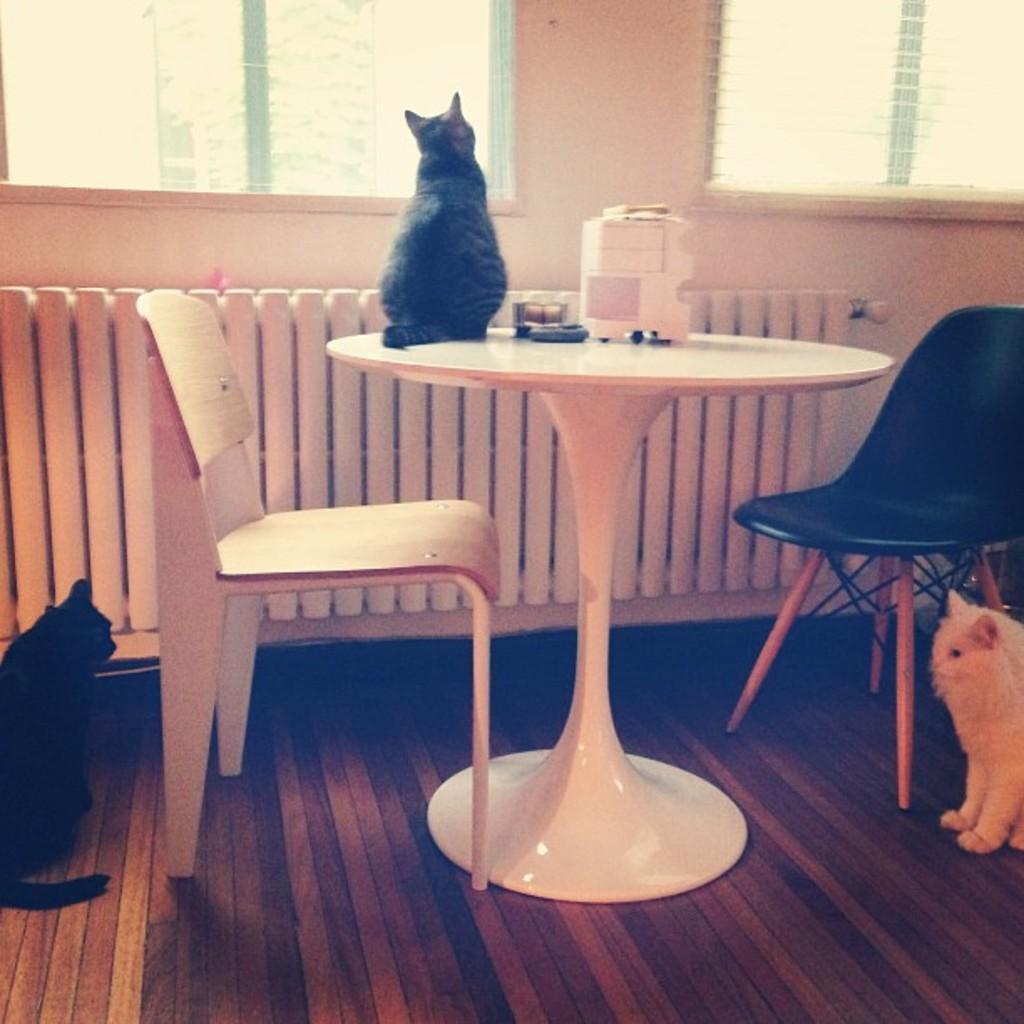How many cats are in the room? There are three cats in the room. Where is one of the cats located? One cat is on the table. Where is another cat located? One cat is on the floor. What type of furniture is in the room? There is a black chair and a white chair in the room. How are the chairs arranged in the room? Both chairs are around the table. What type of twig is the cat holding in the image? There is no twig present in the image; the cats are not holding any objects. 